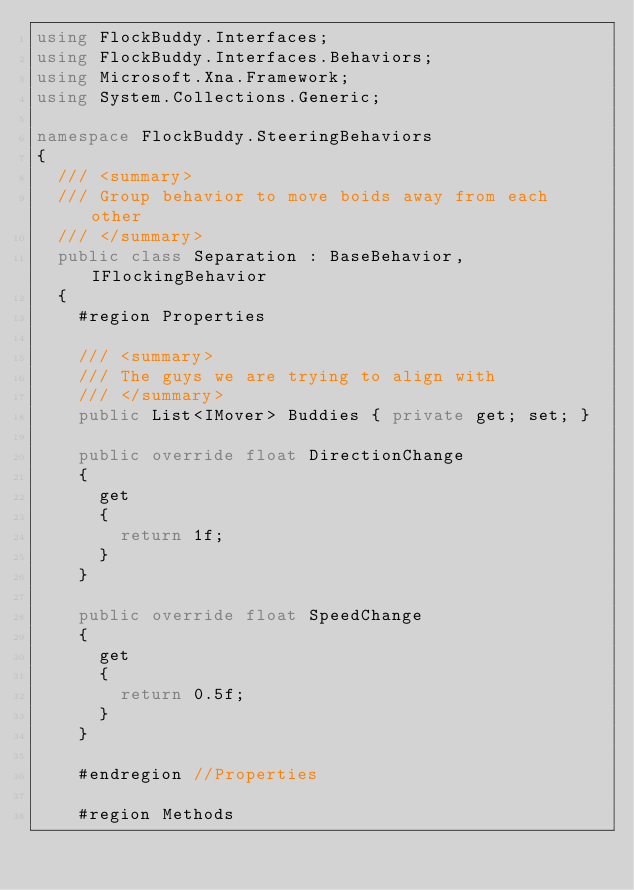Convert code to text. <code><loc_0><loc_0><loc_500><loc_500><_C#_>using FlockBuddy.Interfaces;
using FlockBuddy.Interfaces.Behaviors;
using Microsoft.Xna.Framework;
using System.Collections.Generic;

namespace FlockBuddy.SteeringBehaviors
{
	/// <summary>
	/// Group behavior to move boids away from each other
	/// </summary>
	public class Separation : BaseBehavior, IFlockingBehavior
	{
		#region Properties

		/// <summary>
		/// The guys we are trying to align with
		/// </summary>
		public List<IMover> Buddies { private get; set; }

		public override float DirectionChange
		{
			get
			{
				return 1f;
			}
		}

		public override float SpeedChange
		{
			get
			{
				return 0.5f;
			}
		}

		#endregion //Properties

		#region Methods
</code> 